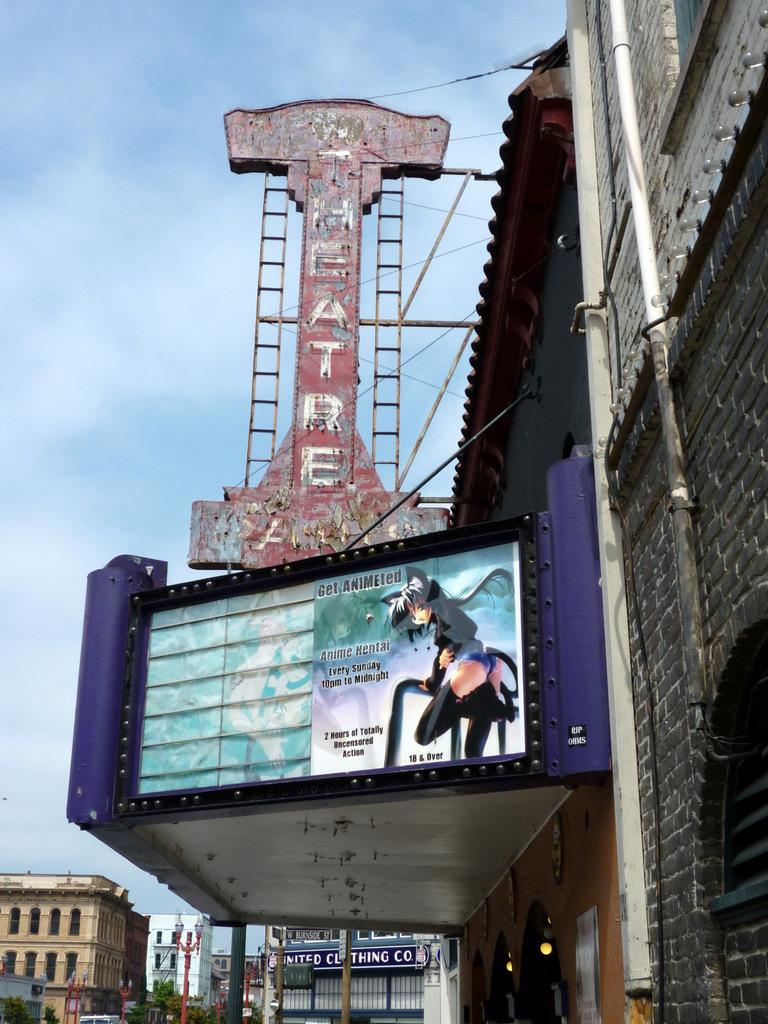<image>
Create a compact narrative representing the image presented. A theater displaying an advertisement for uncensored Japanese hentai. 